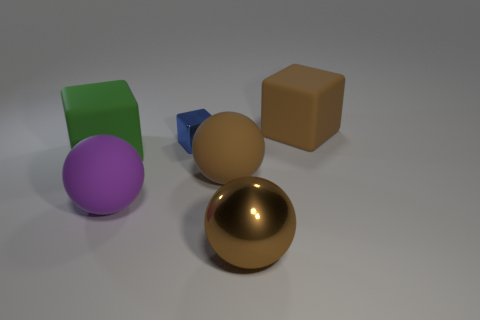Is there another big matte thing of the same shape as the big purple matte thing?
Give a very brief answer. Yes. What shape is the big matte object that is in front of the blue metal thing and right of the large purple object?
Ensure brevity in your answer.  Sphere. Is the big purple thing made of the same material as the thing that is in front of the purple ball?
Your answer should be very brief. No. Are there any large green rubber blocks in front of the large purple rubber ball?
Offer a very short reply. No. How many things are purple blocks or big brown things that are behind the small blue metallic cube?
Offer a terse response. 1. What color is the metal thing behind the large cube that is left of the large brown cube?
Your answer should be compact. Blue. What number of other things are made of the same material as the purple object?
Keep it short and to the point. 3. What number of metal things are either blue blocks or small gray spheres?
Make the answer very short. 1. There is a shiny thing that is the same shape as the purple matte thing; what color is it?
Ensure brevity in your answer.  Brown. How many objects are either green metallic balls or small shiny things?
Offer a terse response. 1. 